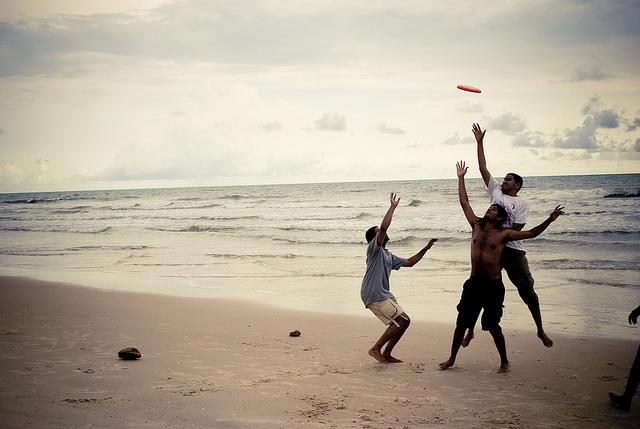What is the shadow doing?
Write a very short answer. Nothing. Who are on the beach?
Give a very brief answer. Men. What is the man pointing at?
Give a very brief answer. Frisbee. How many people are in this photo?
Keep it brief. 3. Are all of the men wearing a shirt?
Write a very short answer. No. Is the man on the right gay or straight?
Keep it brief. Straight. Is the sky overcast?
Concise answer only. Yes. What are the people doing?
Short answer required. Playing frisbee. What are these two people playing?
Keep it brief. Frisbee. Is there a cat?
Quick response, please. No. Are they playing beach ball?
Keep it brief. No. What are the objects in the sky?
Write a very short answer. Clouds. 